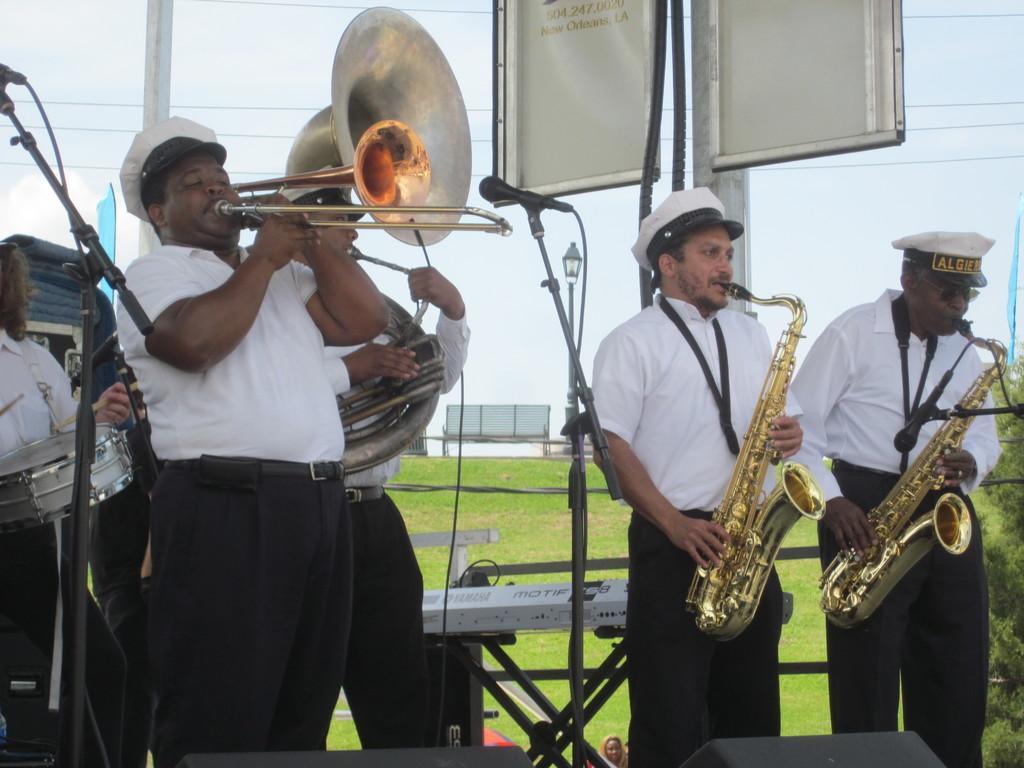Describe this image in one or two sentences. In this picture we can see the group of persons who are playing musical instrument. On the left there is a man who is playing drum. On the bottom we can see speakers, piano, mic and stand. On the top we can see banners. Here we can see electric wires are connected to this poles. In the background we can see benches near to the grass. Here it's a sky. On the right we can see tree near to the blue color flag. 